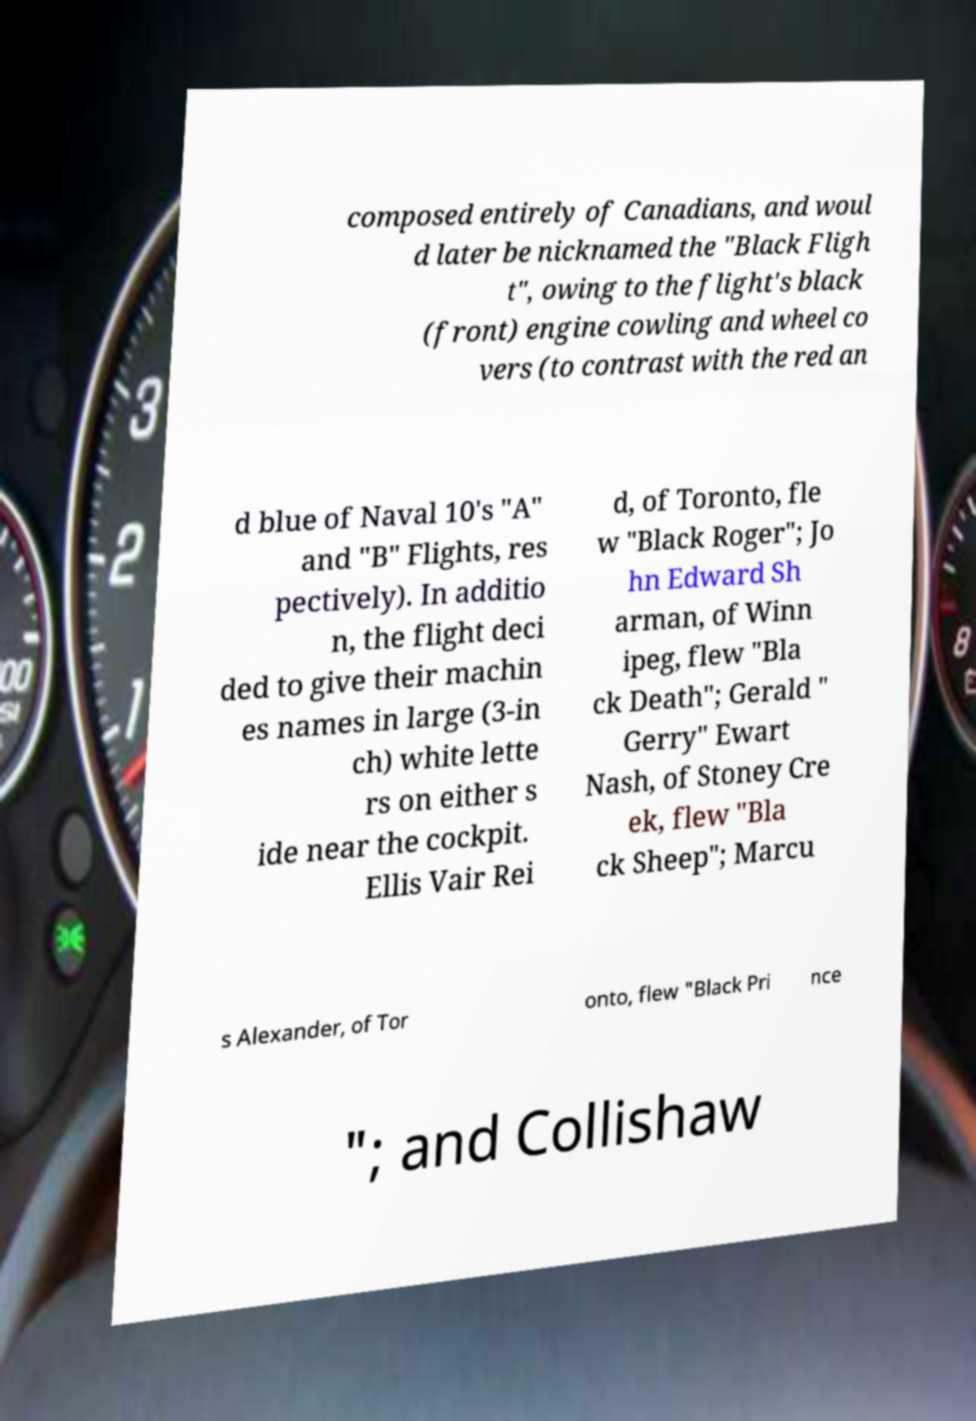I need the written content from this picture converted into text. Can you do that? composed entirely of Canadians, and woul d later be nicknamed the "Black Fligh t", owing to the flight's black (front) engine cowling and wheel co vers (to contrast with the red an d blue of Naval 10's "A" and "B" Flights, res pectively). In additio n, the flight deci ded to give their machin es names in large (3-in ch) white lette rs on either s ide near the cockpit. Ellis Vair Rei d, of Toronto, fle w "Black Roger"; Jo hn Edward Sh arman, of Winn ipeg, flew "Bla ck Death"; Gerald " Gerry" Ewart Nash, of Stoney Cre ek, flew "Bla ck Sheep"; Marcu s Alexander, of Tor onto, flew "Black Pri nce "; and Collishaw 